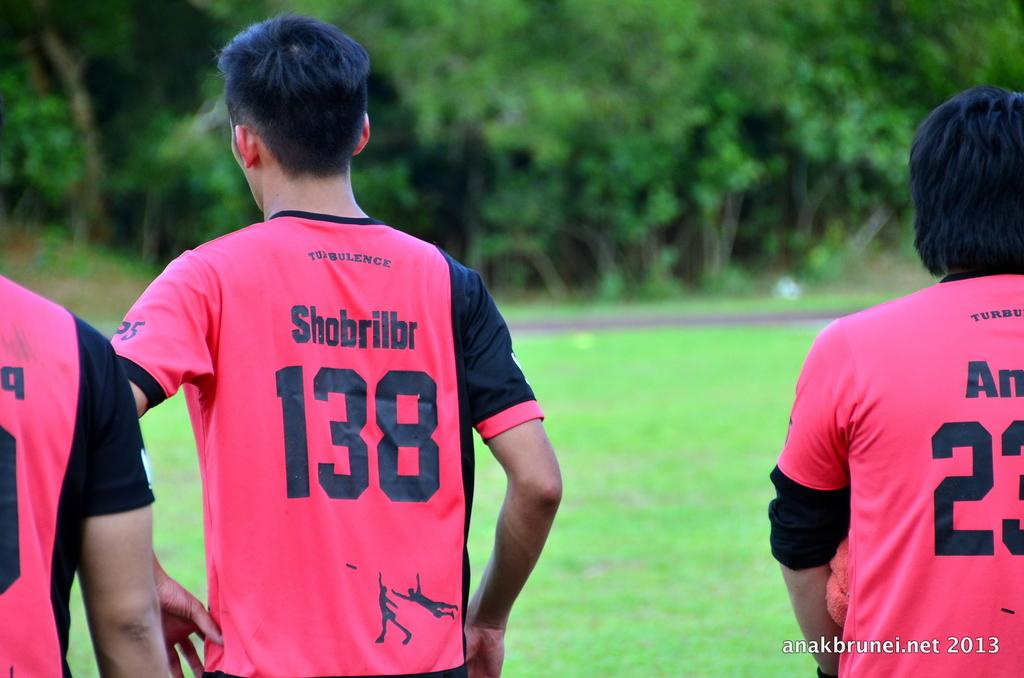Provide a one-sentence caption for the provided image. The player with the name Shobrillbr has the number 138 on his jersey. 